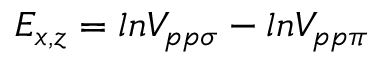<formula> <loc_0><loc_0><loc_500><loc_500>E _ { x , z } = \ln V _ { p p \sigma } - \ln V _ { p p \pi }</formula> 